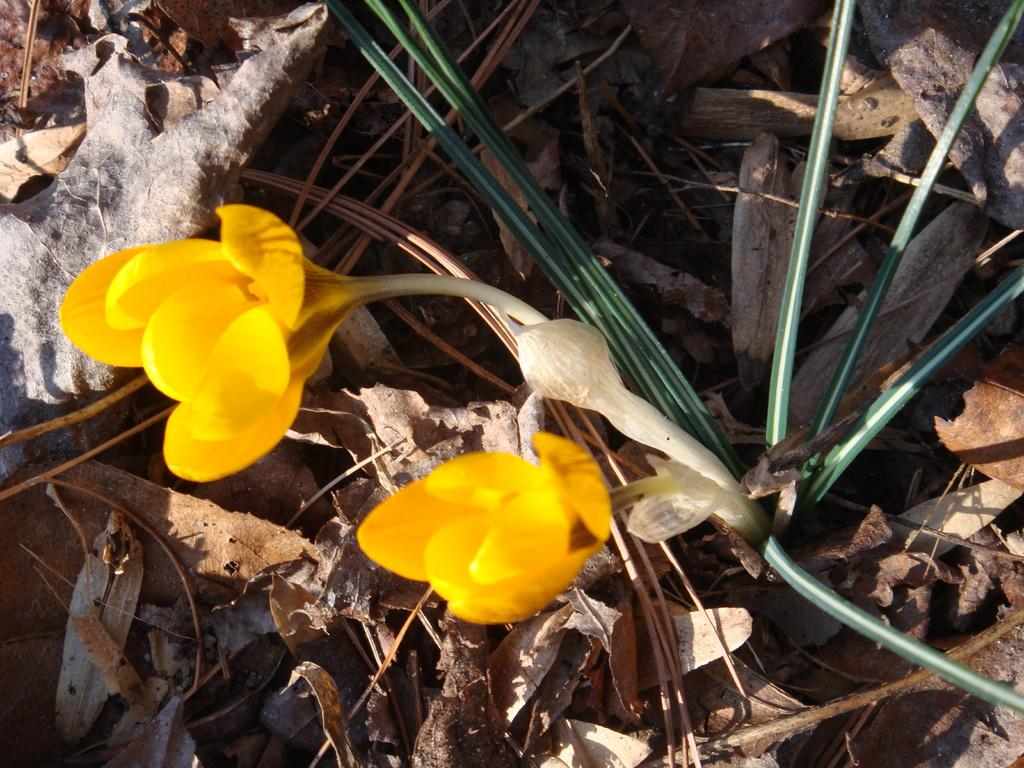What type of plant can be seen in the image? There is a plant with flowers in the image. What else can be found on the ground in the image? There are leaves on the ground in the image. What degree does the father have in the image? There is no mention of a father or any degrees in the image. 